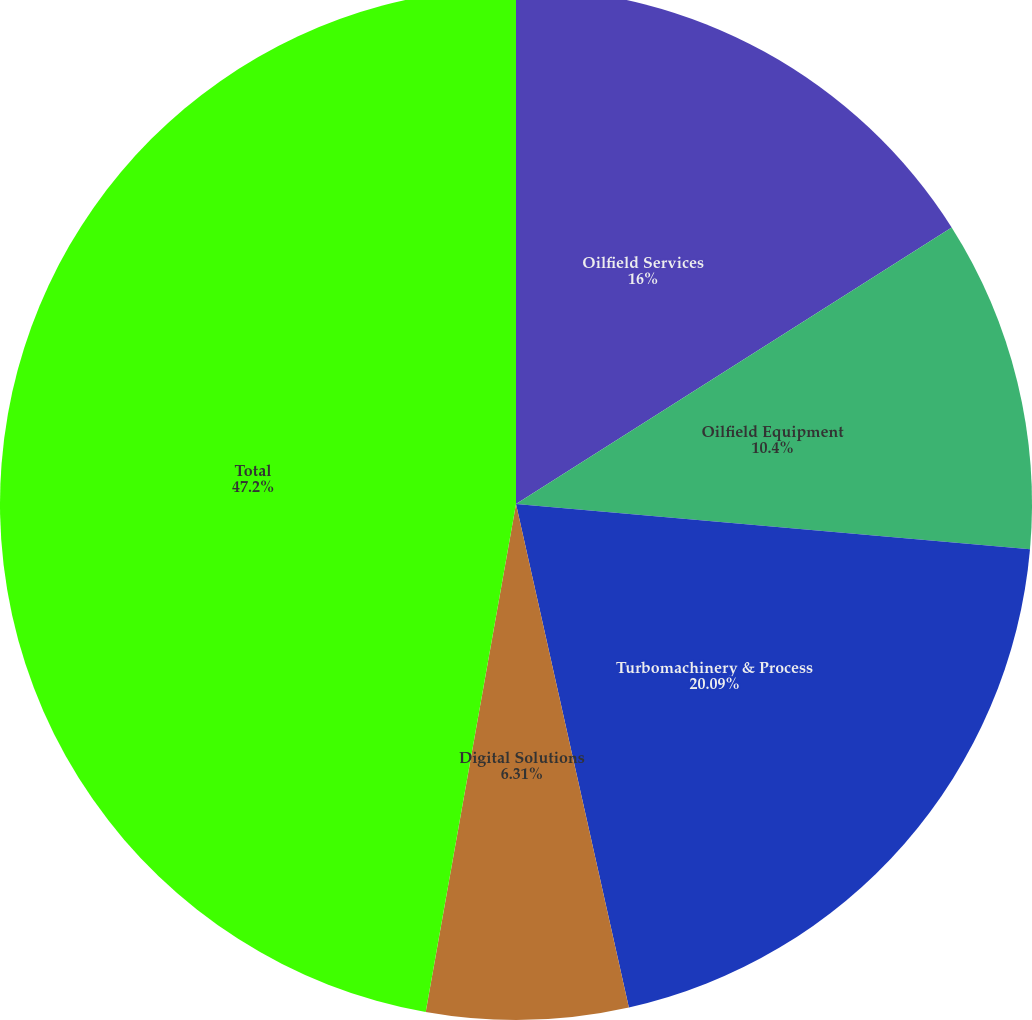Convert chart to OTSL. <chart><loc_0><loc_0><loc_500><loc_500><pie_chart><fcel>Oilfield Services<fcel>Oilfield Equipment<fcel>Turbomachinery & Process<fcel>Digital Solutions<fcel>Total<nl><fcel>16.0%<fcel>10.4%<fcel>20.09%<fcel>6.31%<fcel>47.2%<nl></chart> 